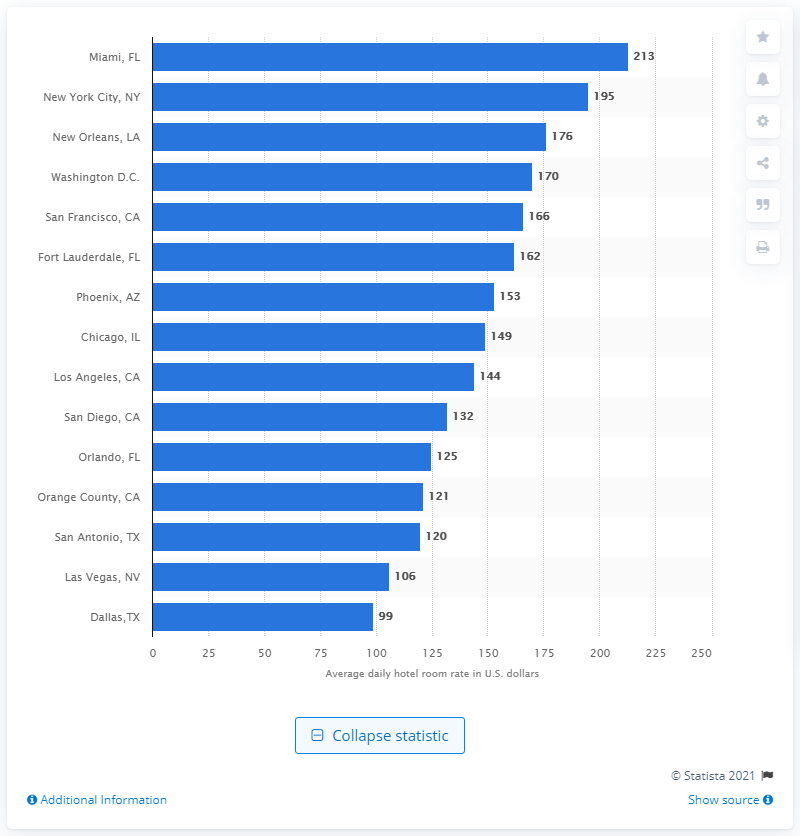Indicate a few pertinent items in this graphic. During the period of 2016 to 2018, the average daily rate of hotels in Miami, Florida was $213. 